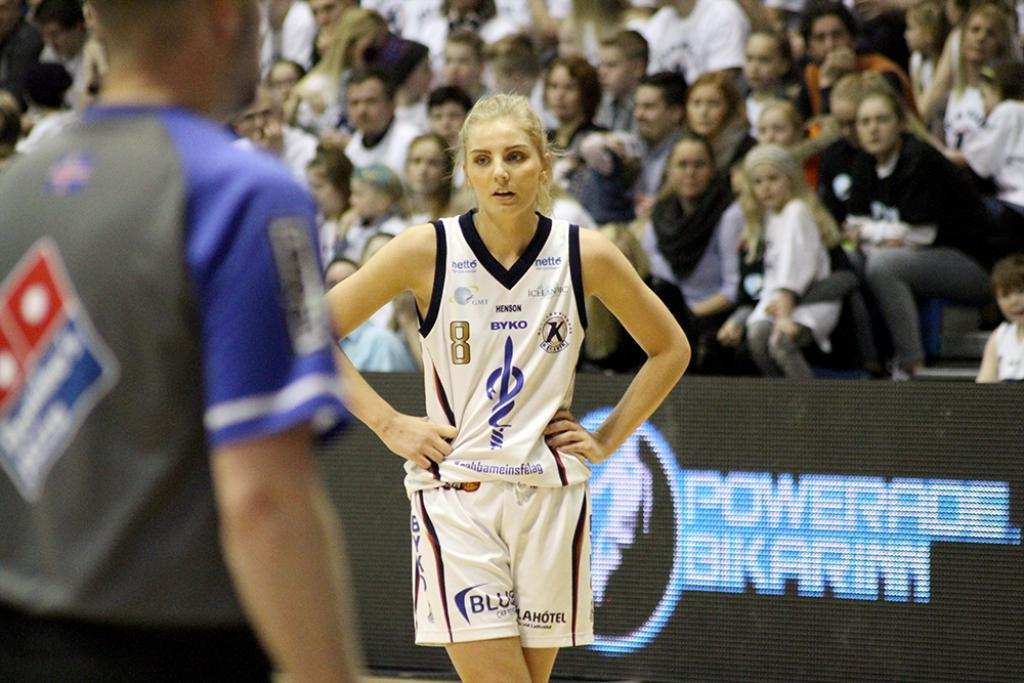<image>
Describe the image concisely. a girl with the number 8 playing basketball 